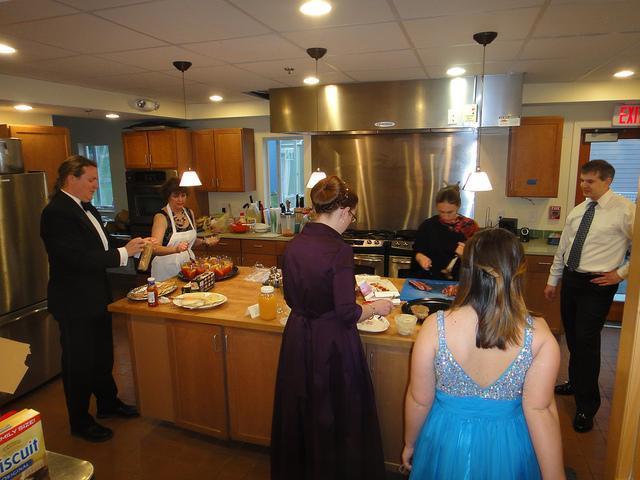How many people are in the picture?
Give a very brief answer. 6. 